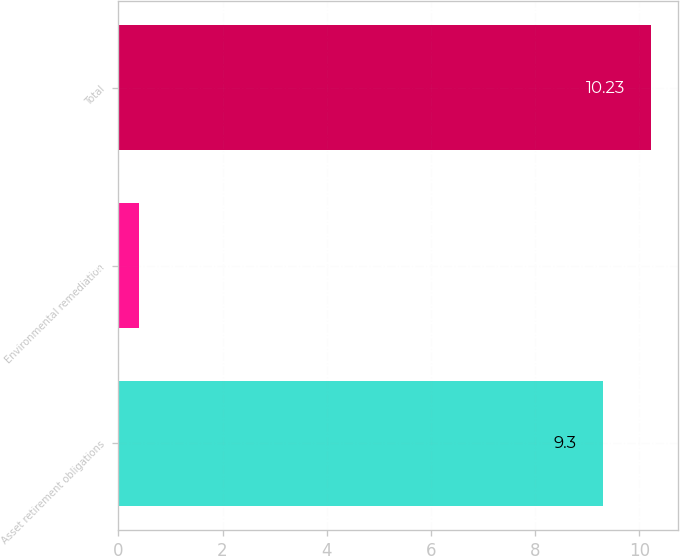<chart> <loc_0><loc_0><loc_500><loc_500><bar_chart><fcel>Asset retirement obligations<fcel>Environmental remediation<fcel>Total<nl><fcel>9.3<fcel>0.4<fcel>10.23<nl></chart> 